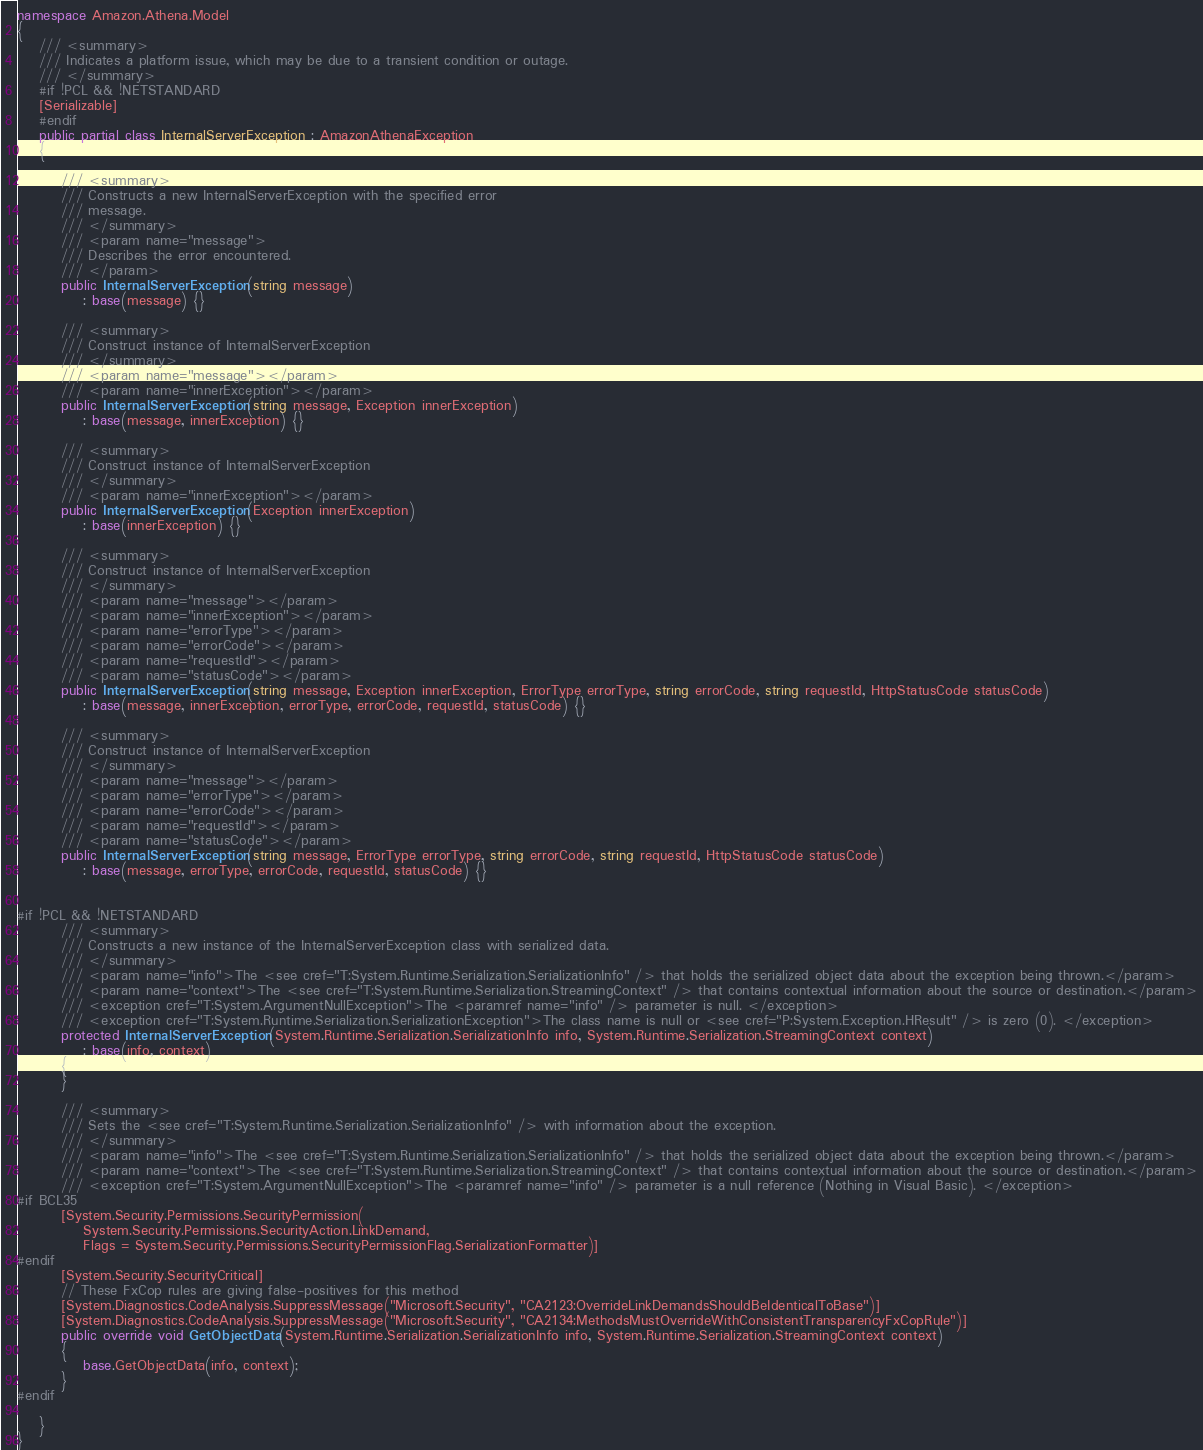<code> <loc_0><loc_0><loc_500><loc_500><_C#_>
namespace Amazon.Athena.Model
{
    /// <summary>
    /// Indicates a platform issue, which may be due to a transient condition or outage.
    /// </summary>
    #if !PCL && !NETSTANDARD
    [Serializable]
    #endif
    public partial class InternalServerException : AmazonAthenaException
    {

        /// <summary>
        /// Constructs a new InternalServerException with the specified error
        /// message.
        /// </summary>
        /// <param name="message">
        /// Describes the error encountered.
        /// </param>
        public InternalServerException(string message) 
            : base(message) {}

        /// <summary>
        /// Construct instance of InternalServerException
        /// </summary>
        /// <param name="message"></param>
        /// <param name="innerException"></param>
        public InternalServerException(string message, Exception innerException) 
            : base(message, innerException) {}

        /// <summary>
        /// Construct instance of InternalServerException
        /// </summary>
        /// <param name="innerException"></param>
        public InternalServerException(Exception innerException) 
            : base(innerException) {}

        /// <summary>
        /// Construct instance of InternalServerException
        /// </summary>
        /// <param name="message"></param>
        /// <param name="innerException"></param>
        /// <param name="errorType"></param>
        /// <param name="errorCode"></param>
        /// <param name="requestId"></param>
        /// <param name="statusCode"></param>
        public InternalServerException(string message, Exception innerException, ErrorType errorType, string errorCode, string requestId, HttpStatusCode statusCode) 
            : base(message, innerException, errorType, errorCode, requestId, statusCode) {}

        /// <summary>
        /// Construct instance of InternalServerException
        /// </summary>
        /// <param name="message"></param>
        /// <param name="errorType"></param>
        /// <param name="errorCode"></param>
        /// <param name="requestId"></param>
        /// <param name="statusCode"></param>
        public InternalServerException(string message, ErrorType errorType, string errorCode, string requestId, HttpStatusCode statusCode) 
            : base(message, errorType, errorCode, requestId, statusCode) {}


#if !PCL && !NETSTANDARD
        /// <summary>
        /// Constructs a new instance of the InternalServerException class with serialized data.
        /// </summary>
        /// <param name="info">The <see cref="T:System.Runtime.Serialization.SerializationInfo" /> that holds the serialized object data about the exception being thrown.</param>
        /// <param name="context">The <see cref="T:System.Runtime.Serialization.StreamingContext" /> that contains contextual information about the source or destination.</param>
        /// <exception cref="T:System.ArgumentNullException">The <paramref name="info" /> parameter is null. </exception>
        /// <exception cref="T:System.Runtime.Serialization.SerializationException">The class name is null or <see cref="P:System.Exception.HResult" /> is zero (0). </exception>
        protected InternalServerException(System.Runtime.Serialization.SerializationInfo info, System.Runtime.Serialization.StreamingContext context)
            : base(info, context)
        {
        }

        /// <summary>
        /// Sets the <see cref="T:System.Runtime.Serialization.SerializationInfo" /> with information about the exception.
        /// </summary>
        /// <param name="info">The <see cref="T:System.Runtime.Serialization.SerializationInfo" /> that holds the serialized object data about the exception being thrown.</param>
        /// <param name="context">The <see cref="T:System.Runtime.Serialization.StreamingContext" /> that contains contextual information about the source or destination.</param>
        /// <exception cref="T:System.ArgumentNullException">The <paramref name="info" /> parameter is a null reference (Nothing in Visual Basic). </exception>
#if BCL35
        [System.Security.Permissions.SecurityPermission(
            System.Security.Permissions.SecurityAction.LinkDemand,
            Flags = System.Security.Permissions.SecurityPermissionFlag.SerializationFormatter)]
#endif
        [System.Security.SecurityCritical]
        // These FxCop rules are giving false-positives for this method
        [System.Diagnostics.CodeAnalysis.SuppressMessage("Microsoft.Security", "CA2123:OverrideLinkDemandsShouldBeIdenticalToBase")]
        [System.Diagnostics.CodeAnalysis.SuppressMessage("Microsoft.Security", "CA2134:MethodsMustOverrideWithConsistentTransparencyFxCopRule")]
        public override void GetObjectData(System.Runtime.Serialization.SerializationInfo info, System.Runtime.Serialization.StreamingContext context)
        {
            base.GetObjectData(info, context);
        }
#endif

    }
}</code> 